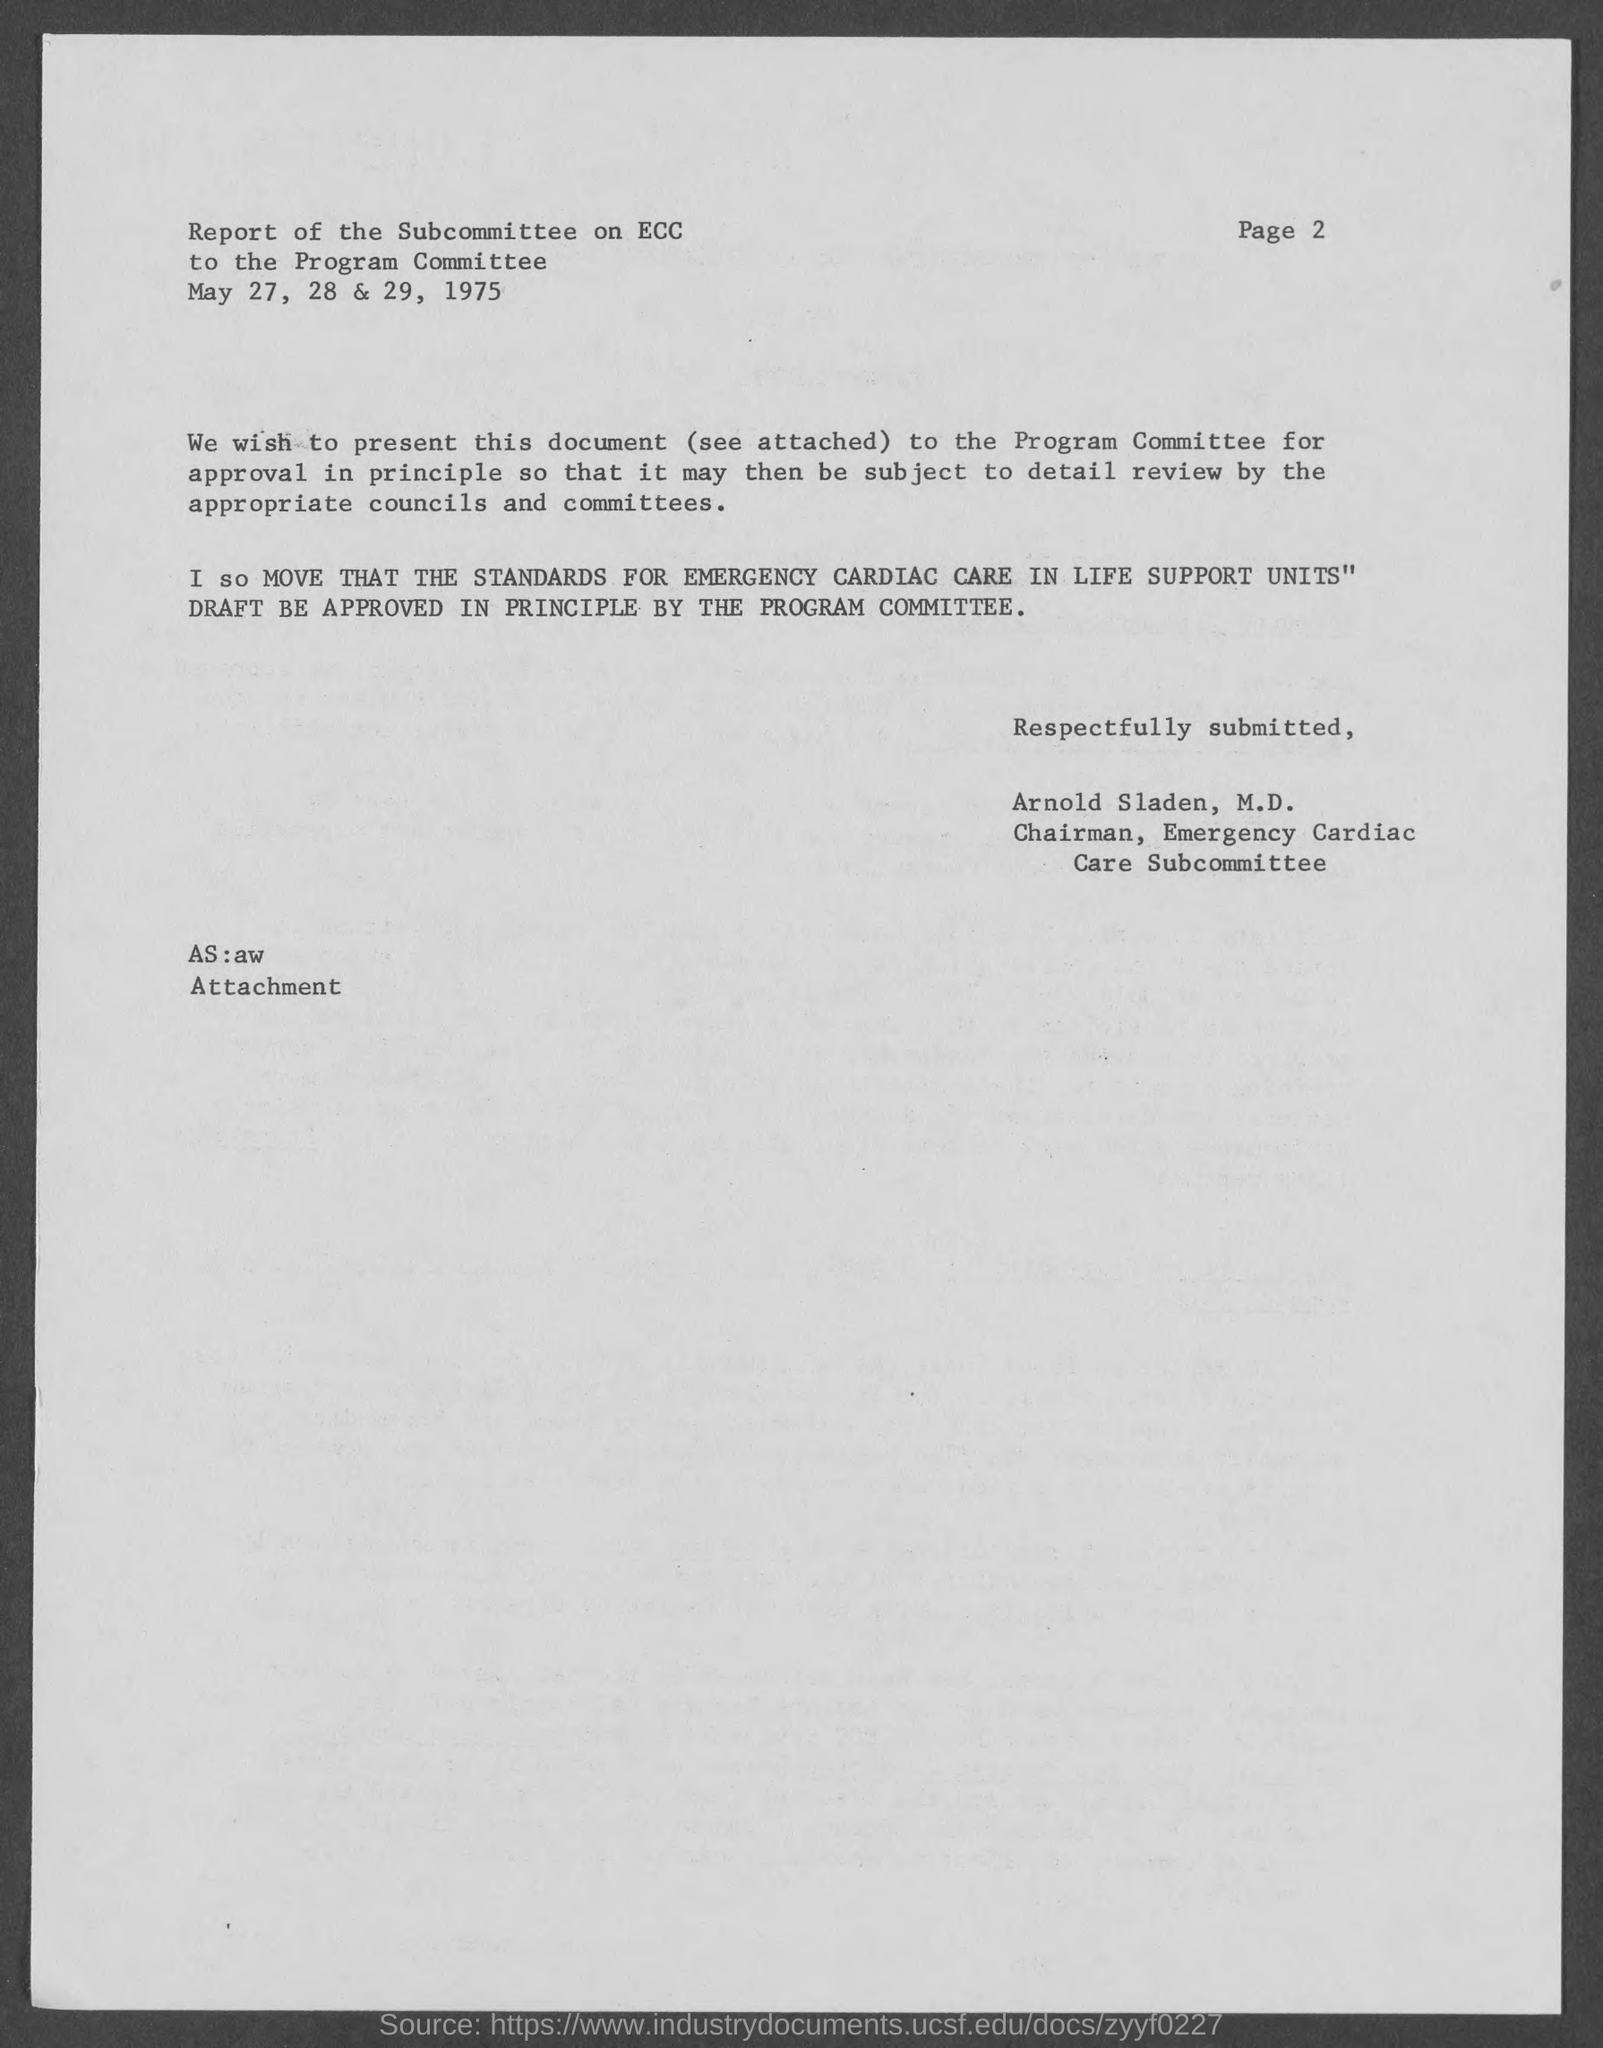List a handful of essential elements in this visual. The page number at the top of the page is PAGE 2. 